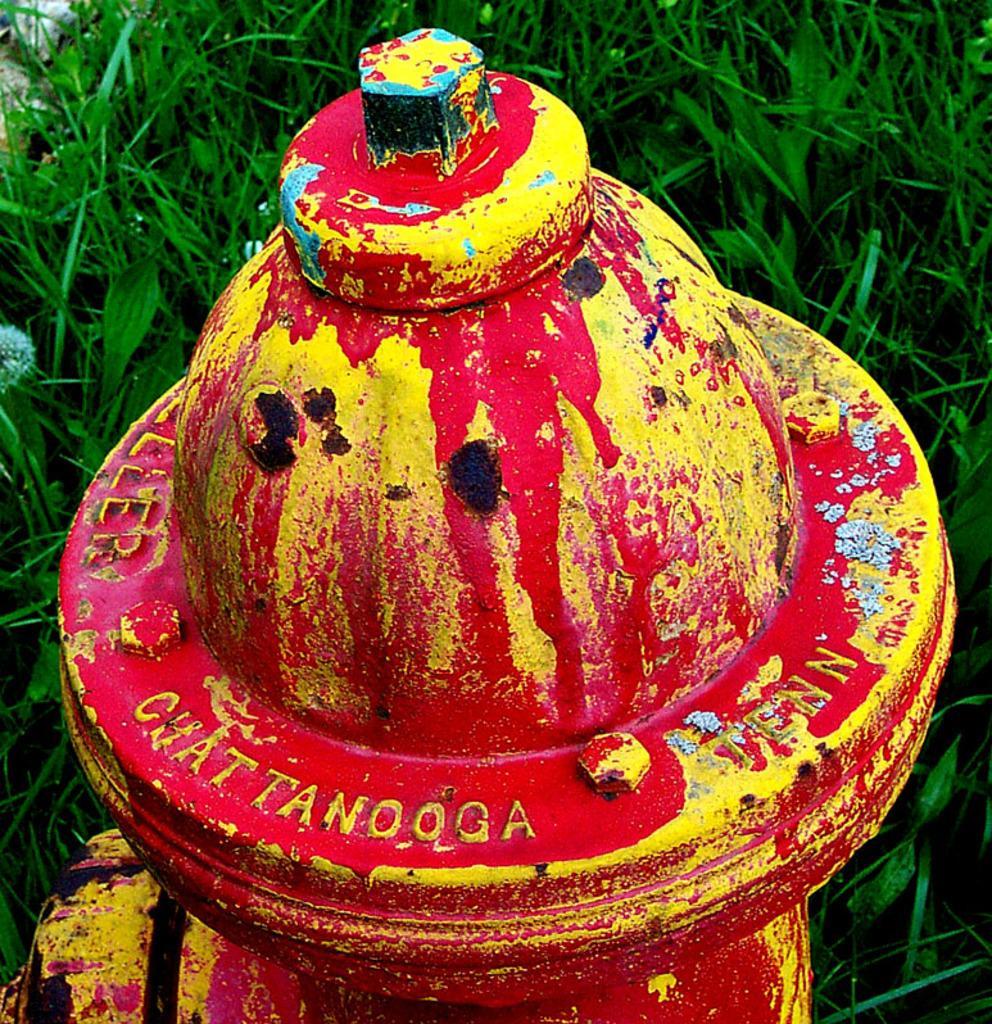Could you give a brief overview of what you see in this image? In this image I can see a metal dome like object with nuts and bolts and some text embossed on it with red and yellow paint kept on the ground. I can see grass behind the object. 